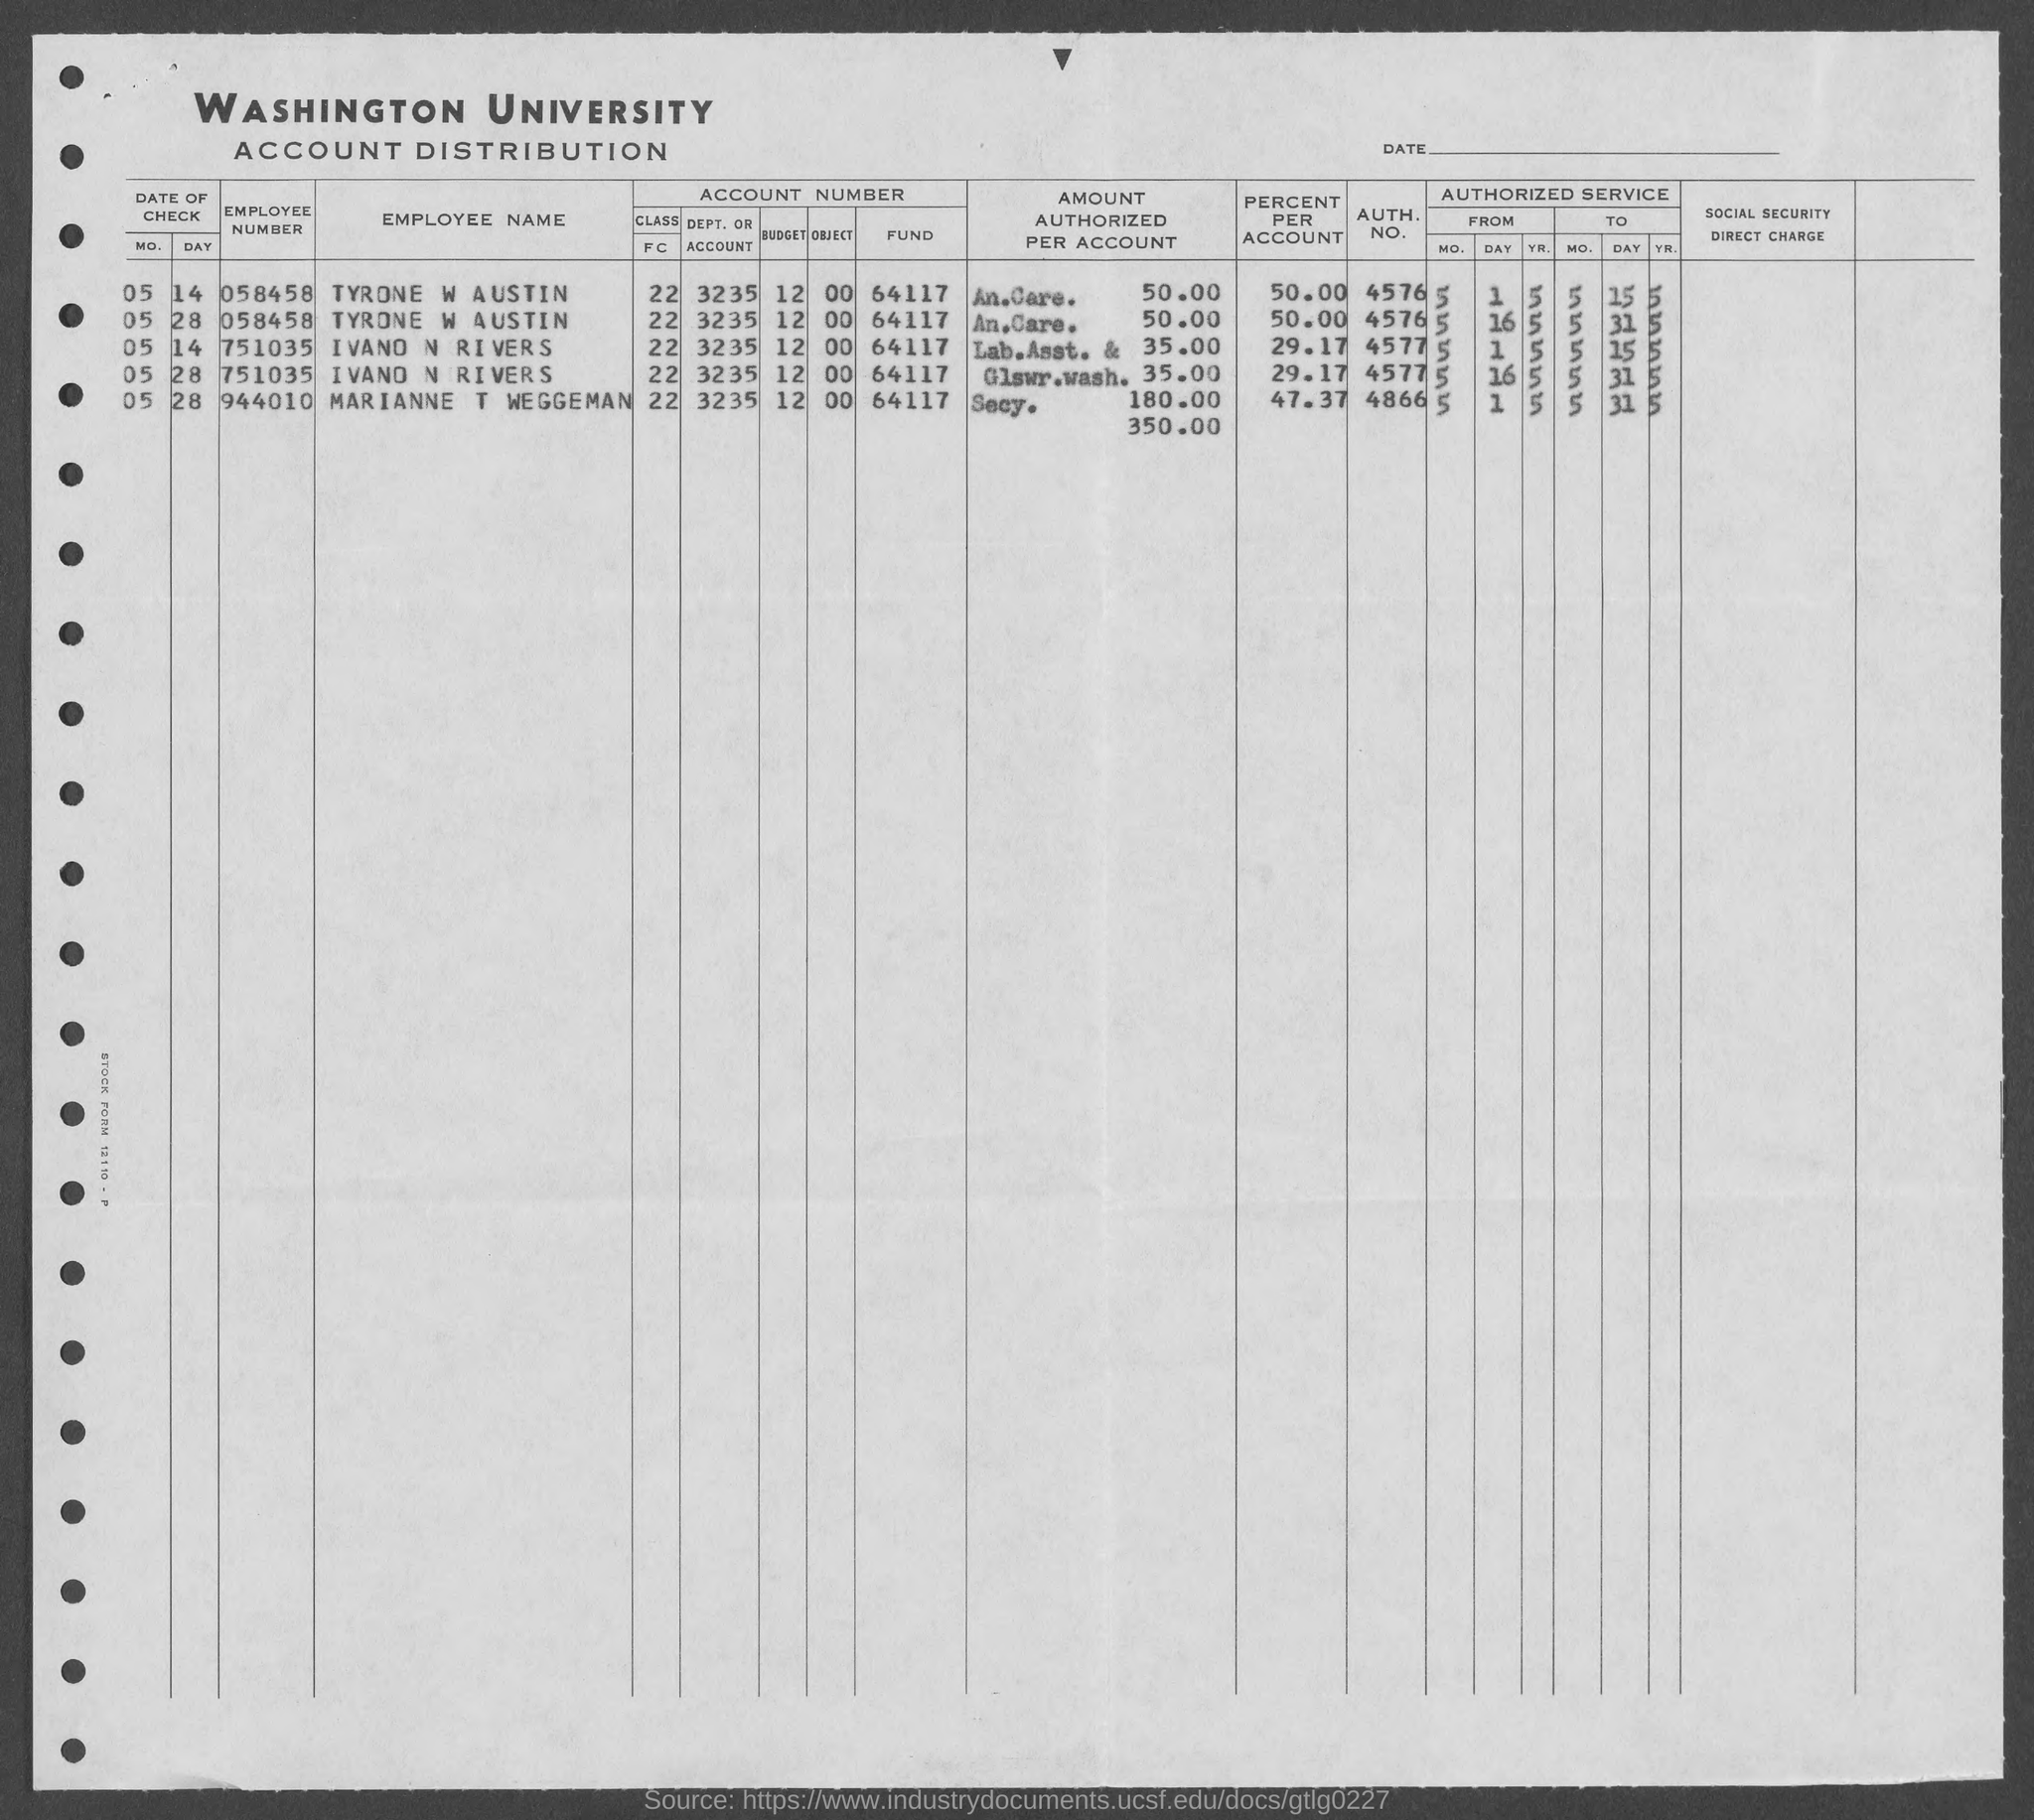Indicate a few pertinent items in this graphic. The percentage of TYRONE W AUSTIN is 50.00%. The account distribution of Washington University is provided in this document. According to the provided information, the employee number of IVANO N RIVERS is 751035. The author of the document is seeking to determine the AUTH. NO. of TYRONE W AUSTIN. The document contains a piece of information that lists the AUTH. NO. as 4576. The employee number of TYRONE W AUSTIN is 058458. 